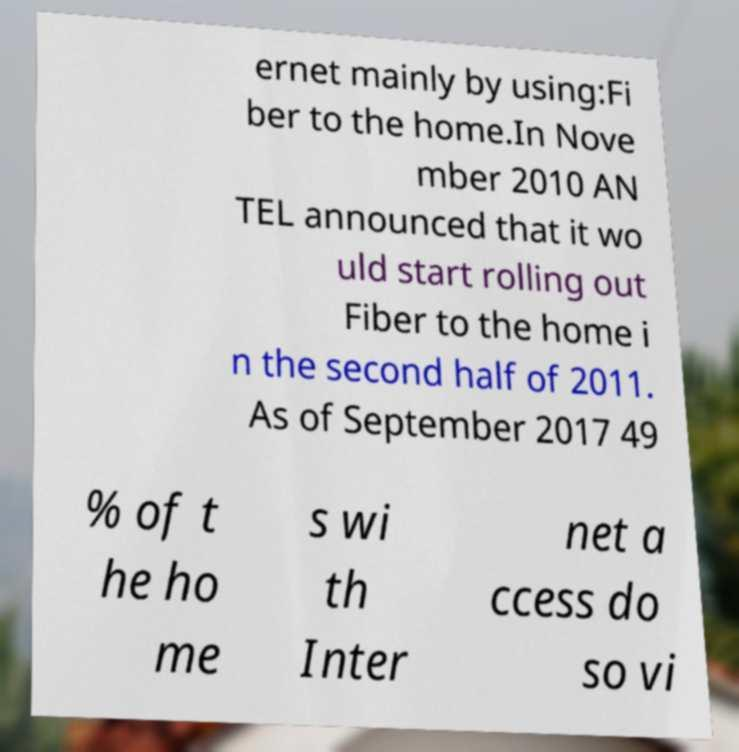Please identify and transcribe the text found in this image. ernet mainly by using:Fi ber to the home.In Nove mber 2010 AN TEL announced that it wo uld start rolling out Fiber to the home i n the second half of 2011. As of September 2017 49 % of t he ho me s wi th Inter net a ccess do so vi 